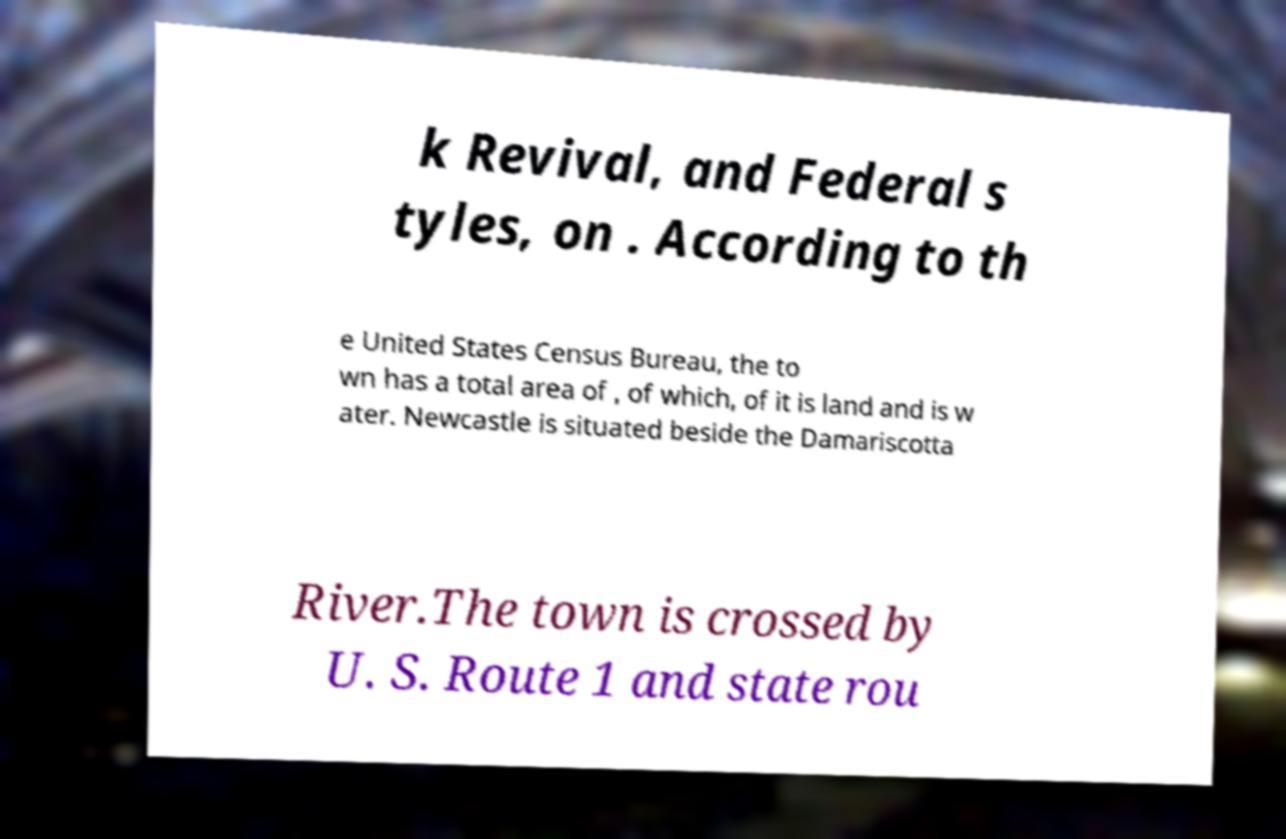Could you assist in decoding the text presented in this image and type it out clearly? k Revival, and Federal s tyles, on . According to th e United States Census Bureau, the to wn has a total area of , of which, of it is land and is w ater. Newcastle is situated beside the Damariscotta River.The town is crossed by U. S. Route 1 and state rou 